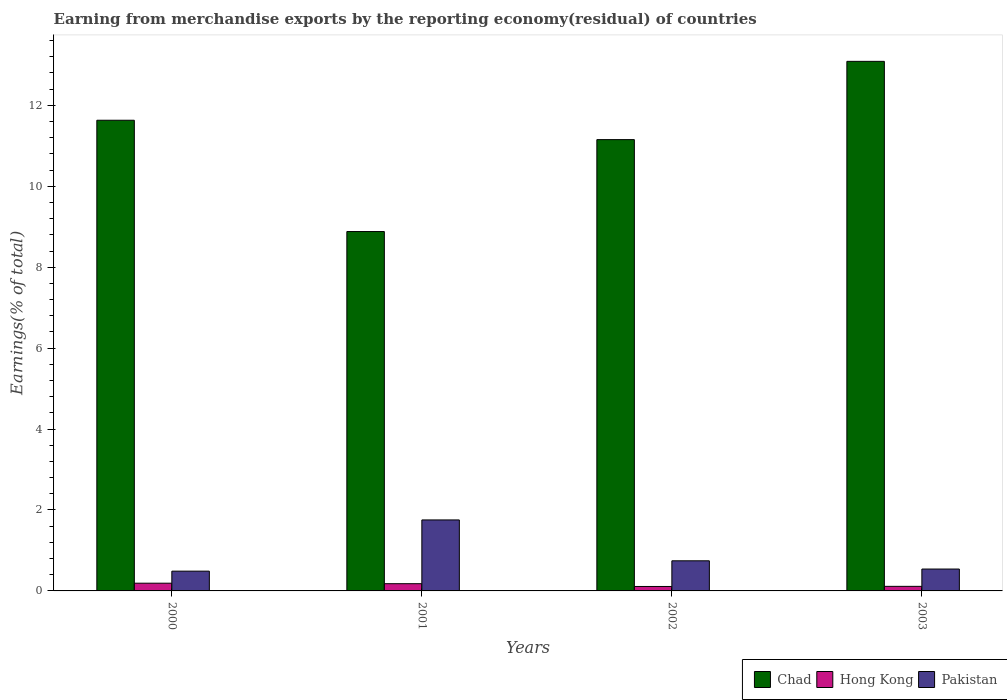How many groups of bars are there?
Keep it short and to the point. 4. Are the number of bars per tick equal to the number of legend labels?
Ensure brevity in your answer.  Yes. Are the number of bars on each tick of the X-axis equal?
Give a very brief answer. Yes. How many bars are there on the 2nd tick from the left?
Your response must be concise. 3. How many bars are there on the 2nd tick from the right?
Provide a succinct answer. 3. What is the percentage of amount earned from merchandise exports in Pakistan in 2001?
Make the answer very short. 1.75. Across all years, what is the maximum percentage of amount earned from merchandise exports in Pakistan?
Offer a terse response. 1.75. Across all years, what is the minimum percentage of amount earned from merchandise exports in Chad?
Your answer should be very brief. 8.88. In which year was the percentage of amount earned from merchandise exports in Hong Kong maximum?
Keep it short and to the point. 2000. What is the total percentage of amount earned from merchandise exports in Pakistan in the graph?
Ensure brevity in your answer.  3.53. What is the difference between the percentage of amount earned from merchandise exports in Pakistan in 2002 and that in 2003?
Your answer should be very brief. 0.2. What is the difference between the percentage of amount earned from merchandise exports in Chad in 2003 and the percentage of amount earned from merchandise exports in Pakistan in 2001?
Give a very brief answer. 11.33. What is the average percentage of amount earned from merchandise exports in Chad per year?
Your answer should be compact. 11.19. In the year 2001, what is the difference between the percentage of amount earned from merchandise exports in Pakistan and percentage of amount earned from merchandise exports in Hong Kong?
Give a very brief answer. 1.58. What is the ratio of the percentage of amount earned from merchandise exports in Hong Kong in 2001 to that in 2003?
Give a very brief answer. 1.58. Is the percentage of amount earned from merchandise exports in Pakistan in 2002 less than that in 2003?
Your answer should be very brief. No. Is the difference between the percentage of amount earned from merchandise exports in Pakistan in 2000 and 2002 greater than the difference between the percentage of amount earned from merchandise exports in Hong Kong in 2000 and 2002?
Ensure brevity in your answer.  No. What is the difference between the highest and the second highest percentage of amount earned from merchandise exports in Chad?
Make the answer very short. 1.46. What is the difference between the highest and the lowest percentage of amount earned from merchandise exports in Chad?
Your answer should be very brief. 4.21. Is the sum of the percentage of amount earned from merchandise exports in Pakistan in 2002 and 2003 greater than the maximum percentage of amount earned from merchandise exports in Hong Kong across all years?
Offer a very short reply. Yes. What does the 1st bar from the left in 2003 represents?
Make the answer very short. Chad. What does the 2nd bar from the right in 2002 represents?
Offer a very short reply. Hong Kong. Is it the case that in every year, the sum of the percentage of amount earned from merchandise exports in Pakistan and percentage of amount earned from merchandise exports in Hong Kong is greater than the percentage of amount earned from merchandise exports in Chad?
Offer a terse response. No. What is the difference between two consecutive major ticks on the Y-axis?
Make the answer very short. 2. Are the values on the major ticks of Y-axis written in scientific E-notation?
Provide a succinct answer. No. Does the graph contain any zero values?
Provide a succinct answer. No. Where does the legend appear in the graph?
Provide a succinct answer. Bottom right. How are the legend labels stacked?
Provide a short and direct response. Horizontal. What is the title of the graph?
Your response must be concise. Earning from merchandise exports by the reporting economy(residual) of countries. Does "Kosovo" appear as one of the legend labels in the graph?
Your answer should be very brief. No. What is the label or title of the Y-axis?
Keep it short and to the point. Earnings(% of total). What is the Earnings(% of total) of Chad in 2000?
Make the answer very short. 11.63. What is the Earnings(% of total) of Hong Kong in 2000?
Offer a very short reply. 0.19. What is the Earnings(% of total) of Pakistan in 2000?
Your answer should be compact. 0.49. What is the Earnings(% of total) in Chad in 2001?
Your answer should be very brief. 8.88. What is the Earnings(% of total) of Hong Kong in 2001?
Your response must be concise. 0.18. What is the Earnings(% of total) in Pakistan in 2001?
Provide a short and direct response. 1.75. What is the Earnings(% of total) in Chad in 2002?
Your answer should be very brief. 11.15. What is the Earnings(% of total) in Hong Kong in 2002?
Offer a terse response. 0.11. What is the Earnings(% of total) of Pakistan in 2002?
Provide a succinct answer. 0.74. What is the Earnings(% of total) in Chad in 2003?
Make the answer very short. 13.09. What is the Earnings(% of total) in Hong Kong in 2003?
Offer a terse response. 0.11. What is the Earnings(% of total) of Pakistan in 2003?
Offer a terse response. 0.54. Across all years, what is the maximum Earnings(% of total) in Chad?
Your answer should be very brief. 13.09. Across all years, what is the maximum Earnings(% of total) in Hong Kong?
Ensure brevity in your answer.  0.19. Across all years, what is the maximum Earnings(% of total) of Pakistan?
Offer a terse response. 1.75. Across all years, what is the minimum Earnings(% of total) of Chad?
Keep it short and to the point. 8.88. Across all years, what is the minimum Earnings(% of total) of Hong Kong?
Offer a very short reply. 0.11. Across all years, what is the minimum Earnings(% of total) of Pakistan?
Your response must be concise. 0.49. What is the total Earnings(% of total) of Chad in the graph?
Keep it short and to the point. 44.75. What is the total Earnings(% of total) of Hong Kong in the graph?
Your answer should be compact. 0.59. What is the total Earnings(% of total) in Pakistan in the graph?
Ensure brevity in your answer.  3.53. What is the difference between the Earnings(% of total) of Chad in 2000 and that in 2001?
Your response must be concise. 2.75. What is the difference between the Earnings(% of total) in Hong Kong in 2000 and that in 2001?
Keep it short and to the point. 0.01. What is the difference between the Earnings(% of total) of Pakistan in 2000 and that in 2001?
Make the answer very short. -1.27. What is the difference between the Earnings(% of total) of Chad in 2000 and that in 2002?
Keep it short and to the point. 0.48. What is the difference between the Earnings(% of total) in Hong Kong in 2000 and that in 2002?
Ensure brevity in your answer.  0.08. What is the difference between the Earnings(% of total) of Pakistan in 2000 and that in 2002?
Your answer should be compact. -0.26. What is the difference between the Earnings(% of total) of Chad in 2000 and that in 2003?
Provide a succinct answer. -1.46. What is the difference between the Earnings(% of total) in Hong Kong in 2000 and that in 2003?
Make the answer very short. 0.08. What is the difference between the Earnings(% of total) in Pakistan in 2000 and that in 2003?
Ensure brevity in your answer.  -0.05. What is the difference between the Earnings(% of total) of Chad in 2001 and that in 2002?
Make the answer very short. -2.27. What is the difference between the Earnings(% of total) in Hong Kong in 2001 and that in 2002?
Offer a terse response. 0.07. What is the difference between the Earnings(% of total) of Pakistan in 2001 and that in 2002?
Make the answer very short. 1.01. What is the difference between the Earnings(% of total) in Chad in 2001 and that in 2003?
Offer a very short reply. -4.21. What is the difference between the Earnings(% of total) in Hong Kong in 2001 and that in 2003?
Make the answer very short. 0.07. What is the difference between the Earnings(% of total) of Pakistan in 2001 and that in 2003?
Keep it short and to the point. 1.21. What is the difference between the Earnings(% of total) in Chad in 2002 and that in 2003?
Provide a succinct answer. -1.93. What is the difference between the Earnings(% of total) of Hong Kong in 2002 and that in 2003?
Keep it short and to the point. -0. What is the difference between the Earnings(% of total) in Pakistan in 2002 and that in 2003?
Offer a very short reply. 0.2. What is the difference between the Earnings(% of total) in Chad in 2000 and the Earnings(% of total) in Hong Kong in 2001?
Offer a very short reply. 11.45. What is the difference between the Earnings(% of total) of Chad in 2000 and the Earnings(% of total) of Pakistan in 2001?
Your answer should be very brief. 9.88. What is the difference between the Earnings(% of total) in Hong Kong in 2000 and the Earnings(% of total) in Pakistan in 2001?
Your response must be concise. -1.56. What is the difference between the Earnings(% of total) of Chad in 2000 and the Earnings(% of total) of Hong Kong in 2002?
Provide a short and direct response. 11.52. What is the difference between the Earnings(% of total) of Chad in 2000 and the Earnings(% of total) of Pakistan in 2002?
Ensure brevity in your answer.  10.89. What is the difference between the Earnings(% of total) of Hong Kong in 2000 and the Earnings(% of total) of Pakistan in 2002?
Provide a short and direct response. -0.55. What is the difference between the Earnings(% of total) in Chad in 2000 and the Earnings(% of total) in Hong Kong in 2003?
Make the answer very short. 11.52. What is the difference between the Earnings(% of total) of Chad in 2000 and the Earnings(% of total) of Pakistan in 2003?
Provide a succinct answer. 11.09. What is the difference between the Earnings(% of total) of Hong Kong in 2000 and the Earnings(% of total) of Pakistan in 2003?
Keep it short and to the point. -0.35. What is the difference between the Earnings(% of total) in Chad in 2001 and the Earnings(% of total) in Hong Kong in 2002?
Provide a short and direct response. 8.77. What is the difference between the Earnings(% of total) of Chad in 2001 and the Earnings(% of total) of Pakistan in 2002?
Ensure brevity in your answer.  8.14. What is the difference between the Earnings(% of total) in Hong Kong in 2001 and the Earnings(% of total) in Pakistan in 2002?
Your response must be concise. -0.57. What is the difference between the Earnings(% of total) of Chad in 2001 and the Earnings(% of total) of Hong Kong in 2003?
Offer a terse response. 8.77. What is the difference between the Earnings(% of total) of Chad in 2001 and the Earnings(% of total) of Pakistan in 2003?
Offer a terse response. 8.34. What is the difference between the Earnings(% of total) in Hong Kong in 2001 and the Earnings(% of total) in Pakistan in 2003?
Keep it short and to the point. -0.36. What is the difference between the Earnings(% of total) in Chad in 2002 and the Earnings(% of total) in Hong Kong in 2003?
Your answer should be very brief. 11.04. What is the difference between the Earnings(% of total) of Chad in 2002 and the Earnings(% of total) of Pakistan in 2003?
Your answer should be compact. 10.61. What is the difference between the Earnings(% of total) of Hong Kong in 2002 and the Earnings(% of total) of Pakistan in 2003?
Make the answer very short. -0.43. What is the average Earnings(% of total) of Chad per year?
Give a very brief answer. 11.19. What is the average Earnings(% of total) of Hong Kong per year?
Ensure brevity in your answer.  0.15. What is the average Earnings(% of total) of Pakistan per year?
Make the answer very short. 0.88. In the year 2000, what is the difference between the Earnings(% of total) in Chad and Earnings(% of total) in Hong Kong?
Ensure brevity in your answer.  11.44. In the year 2000, what is the difference between the Earnings(% of total) of Chad and Earnings(% of total) of Pakistan?
Provide a short and direct response. 11.14. In the year 2000, what is the difference between the Earnings(% of total) of Hong Kong and Earnings(% of total) of Pakistan?
Make the answer very short. -0.3. In the year 2001, what is the difference between the Earnings(% of total) of Chad and Earnings(% of total) of Hong Kong?
Your answer should be compact. 8.7. In the year 2001, what is the difference between the Earnings(% of total) in Chad and Earnings(% of total) in Pakistan?
Offer a very short reply. 7.13. In the year 2001, what is the difference between the Earnings(% of total) of Hong Kong and Earnings(% of total) of Pakistan?
Your answer should be compact. -1.58. In the year 2002, what is the difference between the Earnings(% of total) in Chad and Earnings(% of total) in Hong Kong?
Your answer should be compact. 11.04. In the year 2002, what is the difference between the Earnings(% of total) of Chad and Earnings(% of total) of Pakistan?
Provide a short and direct response. 10.41. In the year 2002, what is the difference between the Earnings(% of total) of Hong Kong and Earnings(% of total) of Pakistan?
Your response must be concise. -0.63. In the year 2003, what is the difference between the Earnings(% of total) in Chad and Earnings(% of total) in Hong Kong?
Offer a very short reply. 12.97. In the year 2003, what is the difference between the Earnings(% of total) in Chad and Earnings(% of total) in Pakistan?
Your answer should be compact. 12.55. In the year 2003, what is the difference between the Earnings(% of total) of Hong Kong and Earnings(% of total) of Pakistan?
Give a very brief answer. -0.43. What is the ratio of the Earnings(% of total) in Chad in 2000 to that in 2001?
Offer a very short reply. 1.31. What is the ratio of the Earnings(% of total) in Hong Kong in 2000 to that in 2001?
Give a very brief answer. 1.07. What is the ratio of the Earnings(% of total) of Pakistan in 2000 to that in 2001?
Provide a succinct answer. 0.28. What is the ratio of the Earnings(% of total) in Chad in 2000 to that in 2002?
Provide a succinct answer. 1.04. What is the ratio of the Earnings(% of total) of Hong Kong in 2000 to that in 2002?
Your answer should be compact. 1.74. What is the ratio of the Earnings(% of total) in Pakistan in 2000 to that in 2002?
Keep it short and to the point. 0.66. What is the ratio of the Earnings(% of total) of Chad in 2000 to that in 2003?
Give a very brief answer. 0.89. What is the ratio of the Earnings(% of total) of Hong Kong in 2000 to that in 2003?
Offer a terse response. 1.69. What is the ratio of the Earnings(% of total) of Pakistan in 2000 to that in 2003?
Keep it short and to the point. 0.9. What is the ratio of the Earnings(% of total) of Chad in 2001 to that in 2002?
Provide a short and direct response. 0.8. What is the ratio of the Earnings(% of total) in Hong Kong in 2001 to that in 2002?
Keep it short and to the point. 1.63. What is the ratio of the Earnings(% of total) of Pakistan in 2001 to that in 2002?
Your answer should be very brief. 2.36. What is the ratio of the Earnings(% of total) of Chad in 2001 to that in 2003?
Your answer should be compact. 0.68. What is the ratio of the Earnings(% of total) of Hong Kong in 2001 to that in 2003?
Your answer should be compact. 1.58. What is the ratio of the Earnings(% of total) in Pakistan in 2001 to that in 2003?
Your response must be concise. 3.24. What is the ratio of the Earnings(% of total) of Chad in 2002 to that in 2003?
Your response must be concise. 0.85. What is the ratio of the Earnings(% of total) of Hong Kong in 2002 to that in 2003?
Keep it short and to the point. 0.97. What is the ratio of the Earnings(% of total) of Pakistan in 2002 to that in 2003?
Keep it short and to the point. 1.38. What is the difference between the highest and the second highest Earnings(% of total) of Chad?
Offer a terse response. 1.46. What is the difference between the highest and the second highest Earnings(% of total) in Hong Kong?
Make the answer very short. 0.01. What is the difference between the highest and the second highest Earnings(% of total) of Pakistan?
Give a very brief answer. 1.01. What is the difference between the highest and the lowest Earnings(% of total) of Chad?
Offer a terse response. 4.21. What is the difference between the highest and the lowest Earnings(% of total) of Hong Kong?
Keep it short and to the point. 0.08. What is the difference between the highest and the lowest Earnings(% of total) in Pakistan?
Offer a terse response. 1.27. 